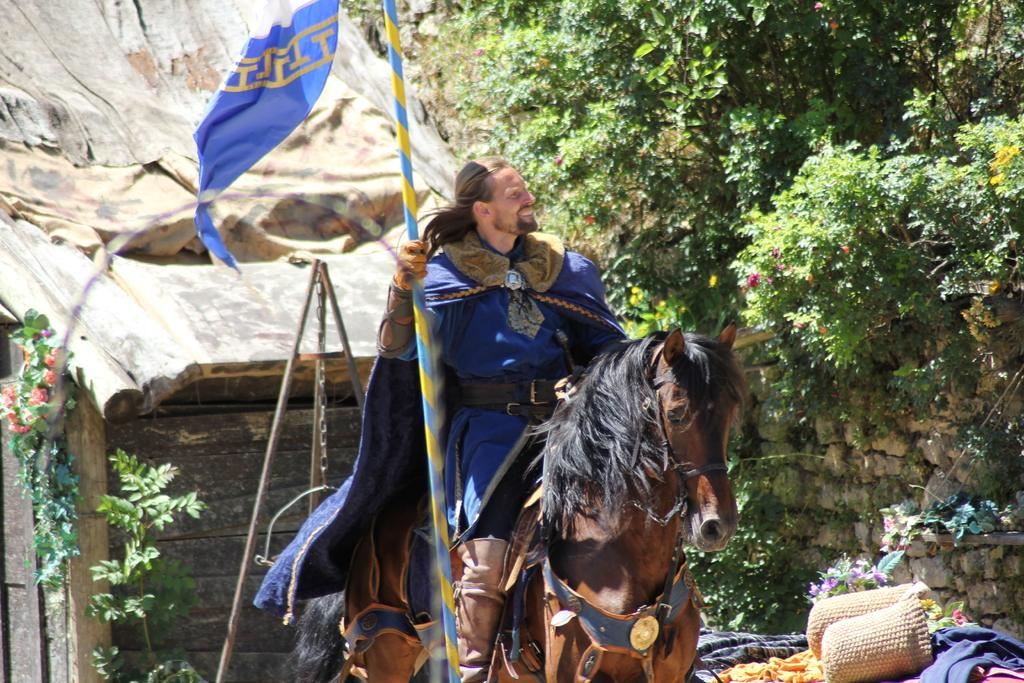What is the main subject of the image? The main subject of the image is a man. What is the man wearing? The man is wearing a coat. What is the man's facial expression? The man is smiling. What is the man holding in his hand? The man is holding a flag pole in one hand. What is the man doing in the image? The man is riding a horse. What can be seen in the background of the image? In the background of the image, there is a hut, trees, a wall, and baskets. How many towns can be seen in the image? There are no towns visible in the image. What type of tree is growing on the man's head? There is no tree growing on the man's head in the image. 